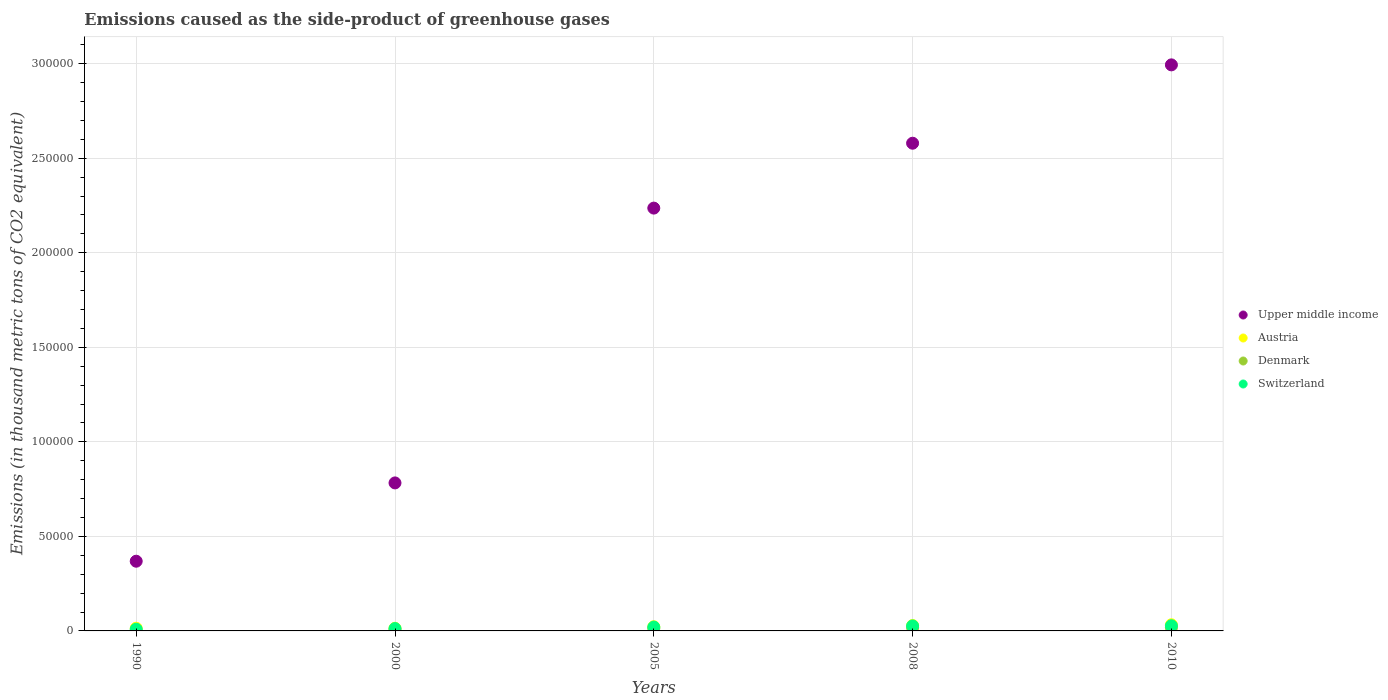Is the number of dotlines equal to the number of legend labels?
Offer a very short reply. Yes. What is the emissions caused as the side-product of greenhouse gases in Upper middle income in 2008?
Ensure brevity in your answer.  2.58e+05. Across all years, what is the maximum emissions caused as the side-product of greenhouse gases in Denmark?
Your answer should be very brief. 1750. Across all years, what is the minimum emissions caused as the side-product of greenhouse gases in Austria?
Provide a short and direct response. 1419.5. What is the total emissions caused as the side-product of greenhouse gases in Austria in the graph?
Keep it short and to the point. 1.12e+04. What is the difference between the emissions caused as the side-product of greenhouse gases in Switzerland in 2005 and that in 2008?
Your answer should be very brief. -609.1. What is the difference between the emissions caused as the side-product of greenhouse gases in Switzerland in 1990 and the emissions caused as the side-product of greenhouse gases in Austria in 2010?
Offer a very short reply. -2351.4. What is the average emissions caused as the side-product of greenhouse gases in Austria per year?
Provide a short and direct response. 2238.64. In the year 2010, what is the difference between the emissions caused as the side-product of greenhouse gases in Upper middle income and emissions caused as the side-product of greenhouse gases in Denmark?
Make the answer very short. 2.98e+05. In how many years, is the emissions caused as the side-product of greenhouse gases in Denmark greater than 90000 thousand metric tons?
Offer a terse response. 0. What is the ratio of the emissions caused as the side-product of greenhouse gases in Upper middle income in 1990 to that in 2008?
Offer a very short reply. 0.14. Is the difference between the emissions caused as the side-product of greenhouse gases in Upper middle income in 2008 and 2010 greater than the difference between the emissions caused as the side-product of greenhouse gases in Denmark in 2008 and 2010?
Your answer should be compact. No. What is the difference between the highest and the second highest emissions caused as the side-product of greenhouse gases in Denmark?
Offer a terse response. 65.5. What is the difference between the highest and the lowest emissions caused as the side-product of greenhouse gases in Upper middle income?
Provide a short and direct response. 2.63e+05. In how many years, is the emissions caused as the side-product of greenhouse gases in Austria greater than the average emissions caused as the side-product of greenhouse gases in Austria taken over all years?
Offer a terse response. 2. Is it the case that in every year, the sum of the emissions caused as the side-product of greenhouse gases in Switzerland and emissions caused as the side-product of greenhouse gases in Austria  is greater than the emissions caused as the side-product of greenhouse gases in Upper middle income?
Provide a short and direct response. No. Does the emissions caused as the side-product of greenhouse gases in Denmark monotonically increase over the years?
Give a very brief answer. Yes. Is the emissions caused as the side-product of greenhouse gases in Switzerland strictly greater than the emissions caused as the side-product of greenhouse gases in Austria over the years?
Give a very brief answer. No. How many years are there in the graph?
Ensure brevity in your answer.  5. Does the graph contain grids?
Your answer should be very brief. Yes. How many legend labels are there?
Make the answer very short. 4. What is the title of the graph?
Offer a terse response. Emissions caused as the side-product of greenhouse gases. Does "Chad" appear as one of the legend labels in the graph?
Make the answer very short. No. What is the label or title of the Y-axis?
Ensure brevity in your answer.  Emissions (in thousand metric tons of CO2 equivalent). What is the Emissions (in thousand metric tons of CO2 equivalent) of Upper middle income in 1990?
Your response must be concise. 3.69e+04. What is the Emissions (in thousand metric tons of CO2 equivalent) of Austria in 1990?
Ensure brevity in your answer.  1437.8. What is the Emissions (in thousand metric tons of CO2 equivalent) of Denmark in 1990?
Your answer should be compact. 88.4. What is the Emissions (in thousand metric tons of CO2 equivalent) in Switzerland in 1990?
Provide a succinct answer. 902.6. What is the Emissions (in thousand metric tons of CO2 equivalent) in Upper middle income in 2000?
Offer a very short reply. 7.83e+04. What is the Emissions (in thousand metric tons of CO2 equivalent) of Austria in 2000?
Make the answer very short. 1419.5. What is the Emissions (in thousand metric tons of CO2 equivalent) of Denmark in 2000?
Your answer should be compact. 767. What is the Emissions (in thousand metric tons of CO2 equivalent) in Switzerland in 2000?
Your answer should be very brief. 1239.2. What is the Emissions (in thousand metric tons of CO2 equivalent) in Upper middle income in 2005?
Make the answer very short. 2.24e+05. What is the Emissions (in thousand metric tons of CO2 equivalent) in Austria in 2005?
Your answer should be compact. 2219.5. What is the Emissions (in thousand metric tons of CO2 equivalent) of Denmark in 2005?
Your answer should be compact. 1302.5. What is the Emissions (in thousand metric tons of CO2 equivalent) in Switzerland in 2005?
Your response must be concise. 2025. What is the Emissions (in thousand metric tons of CO2 equivalent) in Upper middle income in 2008?
Your answer should be compact. 2.58e+05. What is the Emissions (in thousand metric tons of CO2 equivalent) of Austria in 2008?
Make the answer very short. 2862.4. What is the Emissions (in thousand metric tons of CO2 equivalent) of Denmark in 2008?
Offer a very short reply. 1684.5. What is the Emissions (in thousand metric tons of CO2 equivalent) in Switzerland in 2008?
Keep it short and to the point. 2634.1. What is the Emissions (in thousand metric tons of CO2 equivalent) in Upper middle income in 2010?
Make the answer very short. 2.99e+05. What is the Emissions (in thousand metric tons of CO2 equivalent) in Austria in 2010?
Make the answer very short. 3254. What is the Emissions (in thousand metric tons of CO2 equivalent) of Denmark in 2010?
Give a very brief answer. 1750. What is the Emissions (in thousand metric tons of CO2 equivalent) in Switzerland in 2010?
Your response must be concise. 2729. Across all years, what is the maximum Emissions (in thousand metric tons of CO2 equivalent) in Upper middle income?
Offer a very short reply. 2.99e+05. Across all years, what is the maximum Emissions (in thousand metric tons of CO2 equivalent) of Austria?
Offer a terse response. 3254. Across all years, what is the maximum Emissions (in thousand metric tons of CO2 equivalent) of Denmark?
Ensure brevity in your answer.  1750. Across all years, what is the maximum Emissions (in thousand metric tons of CO2 equivalent) of Switzerland?
Provide a short and direct response. 2729. Across all years, what is the minimum Emissions (in thousand metric tons of CO2 equivalent) of Upper middle income?
Offer a terse response. 3.69e+04. Across all years, what is the minimum Emissions (in thousand metric tons of CO2 equivalent) in Austria?
Give a very brief answer. 1419.5. Across all years, what is the minimum Emissions (in thousand metric tons of CO2 equivalent) in Denmark?
Keep it short and to the point. 88.4. Across all years, what is the minimum Emissions (in thousand metric tons of CO2 equivalent) in Switzerland?
Provide a succinct answer. 902.6. What is the total Emissions (in thousand metric tons of CO2 equivalent) in Upper middle income in the graph?
Provide a short and direct response. 8.96e+05. What is the total Emissions (in thousand metric tons of CO2 equivalent) in Austria in the graph?
Provide a succinct answer. 1.12e+04. What is the total Emissions (in thousand metric tons of CO2 equivalent) in Denmark in the graph?
Give a very brief answer. 5592.4. What is the total Emissions (in thousand metric tons of CO2 equivalent) of Switzerland in the graph?
Offer a very short reply. 9529.9. What is the difference between the Emissions (in thousand metric tons of CO2 equivalent) of Upper middle income in 1990 and that in 2000?
Ensure brevity in your answer.  -4.14e+04. What is the difference between the Emissions (in thousand metric tons of CO2 equivalent) in Denmark in 1990 and that in 2000?
Your answer should be very brief. -678.6. What is the difference between the Emissions (in thousand metric tons of CO2 equivalent) in Switzerland in 1990 and that in 2000?
Your answer should be very brief. -336.6. What is the difference between the Emissions (in thousand metric tons of CO2 equivalent) in Upper middle income in 1990 and that in 2005?
Ensure brevity in your answer.  -1.87e+05. What is the difference between the Emissions (in thousand metric tons of CO2 equivalent) of Austria in 1990 and that in 2005?
Offer a terse response. -781.7. What is the difference between the Emissions (in thousand metric tons of CO2 equivalent) of Denmark in 1990 and that in 2005?
Offer a terse response. -1214.1. What is the difference between the Emissions (in thousand metric tons of CO2 equivalent) of Switzerland in 1990 and that in 2005?
Your answer should be compact. -1122.4. What is the difference between the Emissions (in thousand metric tons of CO2 equivalent) in Upper middle income in 1990 and that in 2008?
Ensure brevity in your answer.  -2.21e+05. What is the difference between the Emissions (in thousand metric tons of CO2 equivalent) in Austria in 1990 and that in 2008?
Ensure brevity in your answer.  -1424.6. What is the difference between the Emissions (in thousand metric tons of CO2 equivalent) in Denmark in 1990 and that in 2008?
Your answer should be very brief. -1596.1. What is the difference between the Emissions (in thousand metric tons of CO2 equivalent) of Switzerland in 1990 and that in 2008?
Provide a short and direct response. -1731.5. What is the difference between the Emissions (in thousand metric tons of CO2 equivalent) of Upper middle income in 1990 and that in 2010?
Make the answer very short. -2.63e+05. What is the difference between the Emissions (in thousand metric tons of CO2 equivalent) in Austria in 1990 and that in 2010?
Make the answer very short. -1816.2. What is the difference between the Emissions (in thousand metric tons of CO2 equivalent) in Denmark in 1990 and that in 2010?
Ensure brevity in your answer.  -1661.6. What is the difference between the Emissions (in thousand metric tons of CO2 equivalent) of Switzerland in 1990 and that in 2010?
Your answer should be very brief. -1826.4. What is the difference between the Emissions (in thousand metric tons of CO2 equivalent) of Upper middle income in 2000 and that in 2005?
Your answer should be very brief. -1.45e+05. What is the difference between the Emissions (in thousand metric tons of CO2 equivalent) of Austria in 2000 and that in 2005?
Your answer should be very brief. -800. What is the difference between the Emissions (in thousand metric tons of CO2 equivalent) in Denmark in 2000 and that in 2005?
Provide a succinct answer. -535.5. What is the difference between the Emissions (in thousand metric tons of CO2 equivalent) in Switzerland in 2000 and that in 2005?
Ensure brevity in your answer.  -785.8. What is the difference between the Emissions (in thousand metric tons of CO2 equivalent) of Upper middle income in 2000 and that in 2008?
Your answer should be compact. -1.80e+05. What is the difference between the Emissions (in thousand metric tons of CO2 equivalent) of Austria in 2000 and that in 2008?
Provide a succinct answer. -1442.9. What is the difference between the Emissions (in thousand metric tons of CO2 equivalent) in Denmark in 2000 and that in 2008?
Provide a succinct answer. -917.5. What is the difference between the Emissions (in thousand metric tons of CO2 equivalent) in Switzerland in 2000 and that in 2008?
Ensure brevity in your answer.  -1394.9. What is the difference between the Emissions (in thousand metric tons of CO2 equivalent) of Upper middle income in 2000 and that in 2010?
Give a very brief answer. -2.21e+05. What is the difference between the Emissions (in thousand metric tons of CO2 equivalent) of Austria in 2000 and that in 2010?
Provide a succinct answer. -1834.5. What is the difference between the Emissions (in thousand metric tons of CO2 equivalent) of Denmark in 2000 and that in 2010?
Ensure brevity in your answer.  -983. What is the difference between the Emissions (in thousand metric tons of CO2 equivalent) in Switzerland in 2000 and that in 2010?
Offer a very short reply. -1489.8. What is the difference between the Emissions (in thousand metric tons of CO2 equivalent) in Upper middle income in 2005 and that in 2008?
Keep it short and to the point. -3.43e+04. What is the difference between the Emissions (in thousand metric tons of CO2 equivalent) of Austria in 2005 and that in 2008?
Provide a succinct answer. -642.9. What is the difference between the Emissions (in thousand metric tons of CO2 equivalent) of Denmark in 2005 and that in 2008?
Offer a very short reply. -382. What is the difference between the Emissions (in thousand metric tons of CO2 equivalent) in Switzerland in 2005 and that in 2008?
Ensure brevity in your answer.  -609.1. What is the difference between the Emissions (in thousand metric tons of CO2 equivalent) in Upper middle income in 2005 and that in 2010?
Give a very brief answer. -7.58e+04. What is the difference between the Emissions (in thousand metric tons of CO2 equivalent) of Austria in 2005 and that in 2010?
Your response must be concise. -1034.5. What is the difference between the Emissions (in thousand metric tons of CO2 equivalent) in Denmark in 2005 and that in 2010?
Provide a succinct answer. -447.5. What is the difference between the Emissions (in thousand metric tons of CO2 equivalent) in Switzerland in 2005 and that in 2010?
Keep it short and to the point. -704. What is the difference between the Emissions (in thousand metric tons of CO2 equivalent) of Upper middle income in 2008 and that in 2010?
Provide a short and direct response. -4.14e+04. What is the difference between the Emissions (in thousand metric tons of CO2 equivalent) of Austria in 2008 and that in 2010?
Make the answer very short. -391.6. What is the difference between the Emissions (in thousand metric tons of CO2 equivalent) in Denmark in 2008 and that in 2010?
Offer a terse response. -65.5. What is the difference between the Emissions (in thousand metric tons of CO2 equivalent) of Switzerland in 2008 and that in 2010?
Ensure brevity in your answer.  -94.9. What is the difference between the Emissions (in thousand metric tons of CO2 equivalent) of Upper middle income in 1990 and the Emissions (in thousand metric tons of CO2 equivalent) of Austria in 2000?
Your answer should be very brief. 3.54e+04. What is the difference between the Emissions (in thousand metric tons of CO2 equivalent) of Upper middle income in 1990 and the Emissions (in thousand metric tons of CO2 equivalent) of Denmark in 2000?
Offer a very short reply. 3.61e+04. What is the difference between the Emissions (in thousand metric tons of CO2 equivalent) of Upper middle income in 1990 and the Emissions (in thousand metric tons of CO2 equivalent) of Switzerland in 2000?
Offer a very short reply. 3.56e+04. What is the difference between the Emissions (in thousand metric tons of CO2 equivalent) in Austria in 1990 and the Emissions (in thousand metric tons of CO2 equivalent) in Denmark in 2000?
Provide a short and direct response. 670.8. What is the difference between the Emissions (in thousand metric tons of CO2 equivalent) of Austria in 1990 and the Emissions (in thousand metric tons of CO2 equivalent) of Switzerland in 2000?
Give a very brief answer. 198.6. What is the difference between the Emissions (in thousand metric tons of CO2 equivalent) of Denmark in 1990 and the Emissions (in thousand metric tons of CO2 equivalent) of Switzerland in 2000?
Your response must be concise. -1150.8. What is the difference between the Emissions (in thousand metric tons of CO2 equivalent) of Upper middle income in 1990 and the Emissions (in thousand metric tons of CO2 equivalent) of Austria in 2005?
Your answer should be very brief. 3.46e+04. What is the difference between the Emissions (in thousand metric tons of CO2 equivalent) of Upper middle income in 1990 and the Emissions (in thousand metric tons of CO2 equivalent) of Denmark in 2005?
Provide a short and direct response. 3.56e+04. What is the difference between the Emissions (in thousand metric tons of CO2 equivalent) in Upper middle income in 1990 and the Emissions (in thousand metric tons of CO2 equivalent) in Switzerland in 2005?
Offer a terse response. 3.48e+04. What is the difference between the Emissions (in thousand metric tons of CO2 equivalent) in Austria in 1990 and the Emissions (in thousand metric tons of CO2 equivalent) in Denmark in 2005?
Provide a succinct answer. 135.3. What is the difference between the Emissions (in thousand metric tons of CO2 equivalent) of Austria in 1990 and the Emissions (in thousand metric tons of CO2 equivalent) of Switzerland in 2005?
Keep it short and to the point. -587.2. What is the difference between the Emissions (in thousand metric tons of CO2 equivalent) in Denmark in 1990 and the Emissions (in thousand metric tons of CO2 equivalent) in Switzerland in 2005?
Make the answer very short. -1936.6. What is the difference between the Emissions (in thousand metric tons of CO2 equivalent) of Upper middle income in 1990 and the Emissions (in thousand metric tons of CO2 equivalent) of Austria in 2008?
Offer a terse response. 3.40e+04. What is the difference between the Emissions (in thousand metric tons of CO2 equivalent) of Upper middle income in 1990 and the Emissions (in thousand metric tons of CO2 equivalent) of Denmark in 2008?
Your response must be concise. 3.52e+04. What is the difference between the Emissions (in thousand metric tons of CO2 equivalent) of Upper middle income in 1990 and the Emissions (in thousand metric tons of CO2 equivalent) of Switzerland in 2008?
Your answer should be very brief. 3.42e+04. What is the difference between the Emissions (in thousand metric tons of CO2 equivalent) of Austria in 1990 and the Emissions (in thousand metric tons of CO2 equivalent) of Denmark in 2008?
Keep it short and to the point. -246.7. What is the difference between the Emissions (in thousand metric tons of CO2 equivalent) of Austria in 1990 and the Emissions (in thousand metric tons of CO2 equivalent) of Switzerland in 2008?
Keep it short and to the point. -1196.3. What is the difference between the Emissions (in thousand metric tons of CO2 equivalent) in Denmark in 1990 and the Emissions (in thousand metric tons of CO2 equivalent) in Switzerland in 2008?
Offer a very short reply. -2545.7. What is the difference between the Emissions (in thousand metric tons of CO2 equivalent) of Upper middle income in 1990 and the Emissions (in thousand metric tons of CO2 equivalent) of Austria in 2010?
Ensure brevity in your answer.  3.36e+04. What is the difference between the Emissions (in thousand metric tons of CO2 equivalent) of Upper middle income in 1990 and the Emissions (in thousand metric tons of CO2 equivalent) of Denmark in 2010?
Provide a succinct answer. 3.51e+04. What is the difference between the Emissions (in thousand metric tons of CO2 equivalent) of Upper middle income in 1990 and the Emissions (in thousand metric tons of CO2 equivalent) of Switzerland in 2010?
Provide a succinct answer. 3.41e+04. What is the difference between the Emissions (in thousand metric tons of CO2 equivalent) of Austria in 1990 and the Emissions (in thousand metric tons of CO2 equivalent) of Denmark in 2010?
Your response must be concise. -312.2. What is the difference between the Emissions (in thousand metric tons of CO2 equivalent) of Austria in 1990 and the Emissions (in thousand metric tons of CO2 equivalent) of Switzerland in 2010?
Your answer should be very brief. -1291.2. What is the difference between the Emissions (in thousand metric tons of CO2 equivalent) of Denmark in 1990 and the Emissions (in thousand metric tons of CO2 equivalent) of Switzerland in 2010?
Provide a succinct answer. -2640.6. What is the difference between the Emissions (in thousand metric tons of CO2 equivalent) of Upper middle income in 2000 and the Emissions (in thousand metric tons of CO2 equivalent) of Austria in 2005?
Keep it short and to the point. 7.61e+04. What is the difference between the Emissions (in thousand metric tons of CO2 equivalent) in Upper middle income in 2000 and the Emissions (in thousand metric tons of CO2 equivalent) in Denmark in 2005?
Make the answer very short. 7.70e+04. What is the difference between the Emissions (in thousand metric tons of CO2 equivalent) in Upper middle income in 2000 and the Emissions (in thousand metric tons of CO2 equivalent) in Switzerland in 2005?
Keep it short and to the point. 7.63e+04. What is the difference between the Emissions (in thousand metric tons of CO2 equivalent) of Austria in 2000 and the Emissions (in thousand metric tons of CO2 equivalent) of Denmark in 2005?
Your response must be concise. 117. What is the difference between the Emissions (in thousand metric tons of CO2 equivalent) of Austria in 2000 and the Emissions (in thousand metric tons of CO2 equivalent) of Switzerland in 2005?
Ensure brevity in your answer.  -605.5. What is the difference between the Emissions (in thousand metric tons of CO2 equivalent) of Denmark in 2000 and the Emissions (in thousand metric tons of CO2 equivalent) of Switzerland in 2005?
Provide a succinct answer. -1258. What is the difference between the Emissions (in thousand metric tons of CO2 equivalent) of Upper middle income in 2000 and the Emissions (in thousand metric tons of CO2 equivalent) of Austria in 2008?
Your answer should be compact. 7.54e+04. What is the difference between the Emissions (in thousand metric tons of CO2 equivalent) in Upper middle income in 2000 and the Emissions (in thousand metric tons of CO2 equivalent) in Denmark in 2008?
Your response must be concise. 7.66e+04. What is the difference between the Emissions (in thousand metric tons of CO2 equivalent) of Upper middle income in 2000 and the Emissions (in thousand metric tons of CO2 equivalent) of Switzerland in 2008?
Offer a very short reply. 7.56e+04. What is the difference between the Emissions (in thousand metric tons of CO2 equivalent) in Austria in 2000 and the Emissions (in thousand metric tons of CO2 equivalent) in Denmark in 2008?
Offer a terse response. -265. What is the difference between the Emissions (in thousand metric tons of CO2 equivalent) in Austria in 2000 and the Emissions (in thousand metric tons of CO2 equivalent) in Switzerland in 2008?
Provide a succinct answer. -1214.6. What is the difference between the Emissions (in thousand metric tons of CO2 equivalent) of Denmark in 2000 and the Emissions (in thousand metric tons of CO2 equivalent) of Switzerland in 2008?
Your answer should be compact. -1867.1. What is the difference between the Emissions (in thousand metric tons of CO2 equivalent) of Upper middle income in 2000 and the Emissions (in thousand metric tons of CO2 equivalent) of Austria in 2010?
Your answer should be compact. 7.50e+04. What is the difference between the Emissions (in thousand metric tons of CO2 equivalent) in Upper middle income in 2000 and the Emissions (in thousand metric tons of CO2 equivalent) in Denmark in 2010?
Ensure brevity in your answer.  7.65e+04. What is the difference between the Emissions (in thousand metric tons of CO2 equivalent) of Upper middle income in 2000 and the Emissions (in thousand metric tons of CO2 equivalent) of Switzerland in 2010?
Make the answer very short. 7.56e+04. What is the difference between the Emissions (in thousand metric tons of CO2 equivalent) in Austria in 2000 and the Emissions (in thousand metric tons of CO2 equivalent) in Denmark in 2010?
Your answer should be compact. -330.5. What is the difference between the Emissions (in thousand metric tons of CO2 equivalent) of Austria in 2000 and the Emissions (in thousand metric tons of CO2 equivalent) of Switzerland in 2010?
Your response must be concise. -1309.5. What is the difference between the Emissions (in thousand metric tons of CO2 equivalent) in Denmark in 2000 and the Emissions (in thousand metric tons of CO2 equivalent) in Switzerland in 2010?
Offer a very short reply. -1962. What is the difference between the Emissions (in thousand metric tons of CO2 equivalent) in Upper middle income in 2005 and the Emissions (in thousand metric tons of CO2 equivalent) in Austria in 2008?
Ensure brevity in your answer.  2.21e+05. What is the difference between the Emissions (in thousand metric tons of CO2 equivalent) in Upper middle income in 2005 and the Emissions (in thousand metric tons of CO2 equivalent) in Denmark in 2008?
Offer a very short reply. 2.22e+05. What is the difference between the Emissions (in thousand metric tons of CO2 equivalent) of Upper middle income in 2005 and the Emissions (in thousand metric tons of CO2 equivalent) of Switzerland in 2008?
Keep it short and to the point. 2.21e+05. What is the difference between the Emissions (in thousand metric tons of CO2 equivalent) in Austria in 2005 and the Emissions (in thousand metric tons of CO2 equivalent) in Denmark in 2008?
Provide a short and direct response. 535. What is the difference between the Emissions (in thousand metric tons of CO2 equivalent) of Austria in 2005 and the Emissions (in thousand metric tons of CO2 equivalent) of Switzerland in 2008?
Your answer should be very brief. -414.6. What is the difference between the Emissions (in thousand metric tons of CO2 equivalent) of Denmark in 2005 and the Emissions (in thousand metric tons of CO2 equivalent) of Switzerland in 2008?
Offer a very short reply. -1331.6. What is the difference between the Emissions (in thousand metric tons of CO2 equivalent) in Upper middle income in 2005 and the Emissions (in thousand metric tons of CO2 equivalent) in Austria in 2010?
Your response must be concise. 2.20e+05. What is the difference between the Emissions (in thousand metric tons of CO2 equivalent) of Upper middle income in 2005 and the Emissions (in thousand metric tons of CO2 equivalent) of Denmark in 2010?
Offer a terse response. 2.22e+05. What is the difference between the Emissions (in thousand metric tons of CO2 equivalent) of Upper middle income in 2005 and the Emissions (in thousand metric tons of CO2 equivalent) of Switzerland in 2010?
Your response must be concise. 2.21e+05. What is the difference between the Emissions (in thousand metric tons of CO2 equivalent) in Austria in 2005 and the Emissions (in thousand metric tons of CO2 equivalent) in Denmark in 2010?
Your answer should be very brief. 469.5. What is the difference between the Emissions (in thousand metric tons of CO2 equivalent) of Austria in 2005 and the Emissions (in thousand metric tons of CO2 equivalent) of Switzerland in 2010?
Offer a very short reply. -509.5. What is the difference between the Emissions (in thousand metric tons of CO2 equivalent) of Denmark in 2005 and the Emissions (in thousand metric tons of CO2 equivalent) of Switzerland in 2010?
Your response must be concise. -1426.5. What is the difference between the Emissions (in thousand metric tons of CO2 equivalent) in Upper middle income in 2008 and the Emissions (in thousand metric tons of CO2 equivalent) in Austria in 2010?
Make the answer very short. 2.55e+05. What is the difference between the Emissions (in thousand metric tons of CO2 equivalent) in Upper middle income in 2008 and the Emissions (in thousand metric tons of CO2 equivalent) in Denmark in 2010?
Give a very brief answer. 2.56e+05. What is the difference between the Emissions (in thousand metric tons of CO2 equivalent) in Upper middle income in 2008 and the Emissions (in thousand metric tons of CO2 equivalent) in Switzerland in 2010?
Ensure brevity in your answer.  2.55e+05. What is the difference between the Emissions (in thousand metric tons of CO2 equivalent) in Austria in 2008 and the Emissions (in thousand metric tons of CO2 equivalent) in Denmark in 2010?
Offer a terse response. 1112.4. What is the difference between the Emissions (in thousand metric tons of CO2 equivalent) of Austria in 2008 and the Emissions (in thousand metric tons of CO2 equivalent) of Switzerland in 2010?
Make the answer very short. 133.4. What is the difference between the Emissions (in thousand metric tons of CO2 equivalent) in Denmark in 2008 and the Emissions (in thousand metric tons of CO2 equivalent) in Switzerland in 2010?
Give a very brief answer. -1044.5. What is the average Emissions (in thousand metric tons of CO2 equivalent) in Upper middle income per year?
Offer a terse response. 1.79e+05. What is the average Emissions (in thousand metric tons of CO2 equivalent) of Austria per year?
Provide a short and direct response. 2238.64. What is the average Emissions (in thousand metric tons of CO2 equivalent) in Denmark per year?
Provide a succinct answer. 1118.48. What is the average Emissions (in thousand metric tons of CO2 equivalent) in Switzerland per year?
Your answer should be compact. 1905.98. In the year 1990, what is the difference between the Emissions (in thousand metric tons of CO2 equivalent) of Upper middle income and Emissions (in thousand metric tons of CO2 equivalent) of Austria?
Your answer should be compact. 3.54e+04. In the year 1990, what is the difference between the Emissions (in thousand metric tons of CO2 equivalent) in Upper middle income and Emissions (in thousand metric tons of CO2 equivalent) in Denmark?
Provide a short and direct response. 3.68e+04. In the year 1990, what is the difference between the Emissions (in thousand metric tons of CO2 equivalent) in Upper middle income and Emissions (in thousand metric tons of CO2 equivalent) in Switzerland?
Ensure brevity in your answer.  3.60e+04. In the year 1990, what is the difference between the Emissions (in thousand metric tons of CO2 equivalent) in Austria and Emissions (in thousand metric tons of CO2 equivalent) in Denmark?
Your response must be concise. 1349.4. In the year 1990, what is the difference between the Emissions (in thousand metric tons of CO2 equivalent) in Austria and Emissions (in thousand metric tons of CO2 equivalent) in Switzerland?
Your answer should be compact. 535.2. In the year 1990, what is the difference between the Emissions (in thousand metric tons of CO2 equivalent) in Denmark and Emissions (in thousand metric tons of CO2 equivalent) in Switzerland?
Make the answer very short. -814.2. In the year 2000, what is the difference between the Emissions (in thousand metric tons of CO2 equivalent) of Upper middle income and Emissions (in thousand metric tons of CO2 equivalent) of Austria?
Your response must be concise. 7.69e+04. In the year 2000, what is the difference between the Emissions (in thousand metric tons of CO2 equivalent) in Upper middle income and Emissions (in thousand metric tons of CO2 equivalent) in Denmark?
Give a very brief answer. 7.75e+04. In the year 2000, what is the difference between the Emissions (in thousand metric tons of CO2 equivalent) of Upper middle income and Emissions (in thousand metric tons of CO2 equivalent) of Switzerland?
Offer a very short reply. 7.70e+04. In the year 2000, what is the difference between the Emissions (in thousand metric tons of CO2 equivalent) of Austria and Emissions (in thousand metric tons of CO2 equivalent) of Denmark?
Provide a short and direct response. 652.5. In the year 2000, what is the difference between the Emissions (in thousand metric tons of CO2 equivalent) in Austria and Emissions (in thousand metric tons of CO2 equivalent) in Switzerland?
Offer a very short reply. 180.3. In the year 2000, what is the difference between the Emissions (in thousand metric tons of CO2 equivalent) in Denmark and Emissions (in thousand metric tons of CO2 equivalent) in Switzerland?
Provide a short and direct response. -472.2. In the year 2005, what is the difference between the Emissions (in thousand metric tons of CO2 equivalent) of Upper middle income and Emissions (in thousand metric tons of CO2 equivalent) of Austria?
Provide a succinct answer. 2.21e+05. In the year 2005, what is the difference between the Emissions (in thousand metric tons of CO2 equivalent) of Upper middle income and Emissions (in thousand metric tons of CO2 equivalent) of Denmark?
Make the answer very short. 2.22e+05. In the year 2005, what is the difference between the Emissions (in thousand metric tons of CO2 equivalent) in Upper middle income and Emissions (in thousand metric tons of CO2 equivalent) in Switzerland?
Offer a terse response. 2.22e+05. In the year 2005, what is the difference between the Emissions (in thousand metric tons of CO2 equivalent) of Austria and Emissions (in thousand metric tons of CO2 equivalent) of Denmark?
Your answer should be very brief. 917. In the year 2005, what is the difference between the Emissions (in thousand metric tons of CO2 equivalent) in Austria and Emissions (in thousand metric tons of CO2 equivalent) in Switzerland?
Give a very brief answer. 194.5. In the year 2005, what is the difference between the Emissions (in thousand metric tons of CO2 equivalent) in Denmark and Emissions (in thousand metric tons of CO2 equivalent) in Switzerland?
Make the answer very short. -722.5. In the year 2008, what is the difference between the Emissions (in thousand metric tons of CO2 equivalent) of Upper middle income and Emissions (in thousand metric tons of CO2 equivalent) of Austria?
Your answer should be compact. 2.55e+05. In the year 2008, what is the difference between the Emissions (in thousand metric tons of CO2 equivalent) in Upper middle income and Emissions (in thousand metric tons of CO2 equivalent) in Denmark?
Your answer should be very brief. 2.56e+05. In the year 2008, what is the difference between the Emissions (in thousand metric tons of CO2 equivalent) of Upper middle income and Emissions (in thousand metric tons of CO2 equivalent) of Switzerland?
Your response must be concise. 2.55e+05. In the year 2008, what is the difference between the Emissions (in thousand metric tons of CO2 equivalent) in Austria and Emissions (in thousand metric tons of CO2 equivalent) in Denmark?
Offer a very short reply. 1177.9. In the year 2008, what is the difference between the Emissions (in thousand metric tons of CO2 equivalent) of Austria and Emissions (in thousand metric tons of CO2 equivalent) of Switzerland?
Your answer should be very brief. 228.3. In the year 2008, what is the difference between the Emissions (in thousand metric tons of CO2 equivalent) of Denmark and Emissions (in thousand metric tons of CO2 equivalent) of Switzerland?
Ensure brevity in your answer.  -949.6. In the year 2010, what is the difference between the Emissions (in thousand metric tons of CO2 equivalent) of Upper middle income and Emissions (in thousand metric tons of CO2 equivalent) of Austria?
Provide a succinct answer. 2.96e+05. In the year 2010, what is the difference between the Emissions (in thousand metric tons of CO2 equivalent) of Upper middle income and Emissions (in thousand metric tons of CO2 equivalent) of Denmark?
Keep it short and to the point. 2.98e+05. In the year 2010, what is the difference between the Emissions (in thousand metric tons of CO2 equivalent) of Upper middle income and Emissions (in thousand metric tons of CO2 equivalent) of Switzerland?
Offer a terse response. 2.97e+05. In the year 2010, what is the difference between the Emissions (in thousand metric tons of CO2 equivalent) of Austria and Emissions (in thousand metric tons of CO2 equivalent) of Denmark?
Make the answer very short. 1504. In the year 2010, what is the difference between the Emissions (in thousand metric tons of CO2 equivalent) in Austria and Emissions (in thousand metric tons of CO2 equivalent) in Switzerland?
Offer a terse response. 525. In the year 2010, what is the difference between the Emissions (in thousand metric tons of CO2 equivalent) of Denmark and Emissions (in thousand metric tons of CO2 equivalent) of Switzerland?
Offer a terse response. -979. What is the ratio of the Emissions (in thousand metric tons of CO2 equivalent) of Upper middle income in 1990 to that in 2000?
Provide a succinct answer. 0.47. What is the ratio of the Emissions (in thousand metric tons of CO2 equivalent) of Austria in 1990 to that in 2000?
Provide a short and direct response. 1.01. What is the ratio of the Emissions (in thousand metric tons of CO2 equivalent) in Denmark in 1990 to that in 2000?
Keep it short and to the point. 0.12. What is the ratio of the Emissions (in thousand metric tons of CO2 equivalent) of Switzerland in 1990 to that in 2000?
Offer a terse response. 0.73. What is the ratio of the Emissions (in thousand metric tons of CO2 equivalent) in Upper middle income in 1990 to that in 2005?
Offer a terse response. 0.16. What is the ratio of the Emissions (in thousand metric tons of CO2 equivalent) of Austria in 1990 to that in 2005?
Offer a terse response. 0.65. What is the ratio of the Emissions (in thousand metric tons of CO2 equivalent) of Denmark in 1990 to that in 2005?
Offer a terse response. 0.07. What is the ratio of the Emissions (in thousand metric tons of CO2 equivalent) of Switzerland in 1990 to that in 2005?
Ensure brevity in your answer.  0.45. What is the ratio of the Emissions (in thousand metric tons of CO2 equivalent) in Upper middle income in 1990 to that in 2008?
Ensure brevity in your answer.  0.14. What is the ratio of the Emissions (in thousand metric tons of CO2 equivalent) of Austria in 1990 to that in 2008?
Make the answer very short. 0.5. What is the ratio of the Emissions (in thousand metric tons of CO2 equivalent) of Denmark in 1990 to that in 2008?
Keep it short and to the point. 0.05. What is the ratio of the Emissions (in thousand metric tons of CO2 equivalent) of Switzerland in 1990 to that in 2008?
Your response must be concise. 0.34. What is the ratio of the Emissions (in thousand metric tons of CO2 equivalent) in Upper middle income in 1990 to that in 2010?
Provide a short and direct response. 0.12. What is the ratio of the Emissions (in thousand metric tons of CO2 equivalent) of Austria in 1990 to that in 2010?
Ensure brevity in your answer.  0.44. What is the ratio of the Emissions (in thousand metric tons of CO2 equivalent) of Denmark in 1990 to that in 2010?
Your answer should be very brief. 0.05. What is the ratio of the Emissions (in thousand metric tons of CO2 equivalent) of Switzerland in 1990 to that in 2010?
Your answer should be very brief. 0.33. What is the ratio of the Emissions (in thousand metric tons of CO2 equivalent) in Upper middle income in 2000 to that in 2005?
Ensure brevity in your answer.  0.35. What is the ratio of the Emissions (in thousand metric tons of CO2 equivalent) in Austria in 2000 to that in 2005?
Offer a terse response. 0.64. What is the ratio of the Emissions (in thousand metric tons of CO2 equivalent) in Denmark in 2000 to that in 2005?
Your response must be concise. 0.59. What is the ratio of the Emissions (in thousand metric tons of CO2 equivalent) of Switzerland in 2000 to that in 2005?
Offer a very short reply. 0.61. What is the ratio of the Emissions (in thousand metric tons of CO2 equivalent) in Upper middle income in 2000 to that in 2008?
Your response must be concise. 0.3. What is the ratio of the Emissions (in thousand metric tons of CO2 equivalent) in Austria in 2000 to that in 2008?
Offer a terse response. 0.5. What is the ratio of the Emissions (in thousand metric tons of CO2 equivalent) in Denmark in 2000 to that in 2008?
Provide a succinct answer. 0.46. What is the ratio of the Emissions (in thousand metric tons of CO2 equivalent) in Switzerland in 2000 to that in 2008?
Ensure brevity in your answer.  0.47. What is the ratio of the Emissions (in thousand metric tons of CO2 equivalent) of Upper middle income in 2000 to that in 2010?
Provide a short and direct response. 0.26. What is the ratio of the Emissions (in thousand metric tons of CO2 equivalent) of Austria in 2000 to that in 2010?
Offer a very short reply. 0.44. What is the ratio of the Emissions (in thousand metric tons of CO2 equivalent) in Denmark in 2000 to that in 2010?
Offer a terse response. 0.44. What is the ratio of the Emissions (in thousand metric tons of CO2 equivalent) in Switzerland in 2000 to that in 2010?
Make the answer very short. 0.45. What is the ratio of the Emissions (in thousand metric tons of CO2 equivalent) in Upper middle income in 2005 to that in 2008?
Give a very brief answer. 0.87. What is the ratio of the Emissions (in thousand metric tons of CO2 equivalent) of Austria in 2005 to that in 2008?
Offer a very short reply. 0.78. What is the ratio of the Emissions (in thousand metric tons of CO2 equivalent) of Denmark in 2005 to that in 2008?
Give a very brief answer. 0.77. What is the ratio of the Emissions (in thousand metric tons of CO2 equivalent) of Switzerland in 2005 to that in 2008?
Provide a succinct answer. 0.77. What is the ratio of the Emissions (in thousand metric tons of CO2 equivalent) in Upper middle income in 2005 to that in 2010?
Provide a succinct answer. 0.75. What is the ratio of the Emissions (in thousand metric tons of CO2 equivalent) in Austria in 2005 to that in 2010?
Offer a terse response. 0.68. What is the ratio of the Emissions (in thousand metric tons of CO2 equivalent) of Denmark in 2005 to that in 2010?
Provide a succinct answer. 0.74. What is the ratio of the Emissions (in thousand metric tons of CO2 equivalent) in Switzerland in 2005 to that in 2010?
Your response must be concise. 0.74. What is the ratio of the Emissions (in thousand metric tons of CO2 equivalent) in Upper middle income in 2008 to that in 2010?
Your response must be concise. 0.86. What is the ratio of the Emissions (in thousand metric tons of CO2 equivalent) of Austria in 2008 to that in 2010?
Offer a terse response. 0.88. What is the ratio of the Emissions (in thousand metric tons of CO2 equivalent) in Denmark in 2008 to that in 2010?
Offer a very short reply. 0.96. What is the ratio of the Emissions (in thousand metric tons of CO2 equivalent) of Switzerland in 2008 to that in 2010?
Provide a short and direct response. 0.97. What is the difference between the highest and the second highest Emissions (in thousand metric tons of CO2 equivalent) of Upper middle income?
Offer a terse response. 4.14e+04. What is the difference between the highest and the second highest Emissions (in thousand metric tons of CO2 equivalent) of Austria?
Offer a terse response. 391.6. What is the difference between the highest and the second highest Emissions (in thousand metric tons of CO2 equivalent) in Denmark?
Offer a terse response. 65.5. What is the difference between the highest and the second highest Emissions (in thousand metric tons of CO2 equivalent) of Switzerland?
Ensure brevity in your answer.  94.9. What is the difference between the highest and the lowest Emissions (in thousand metric tons of CO2 equivalent) in Upper middle income?
Ensure brevity in your answer.  2.63e+05. What is the difference between the highest and the lowest Emissions (in thousand metric tons of CO2 equivalent) of Austria?
Offer a terse response. 1834.5. What is the difference between the highest and the lowest Emissions (in thousand metric tons of CO2 equivalent) in Denmark?
Ensure brevity in your answer.  1661.6. What is the difference between the highest and the lowest Emissions (in thousand metric tons of CO2 equivalent) of Switzerland?
Your response must be concise. 1826.4. 